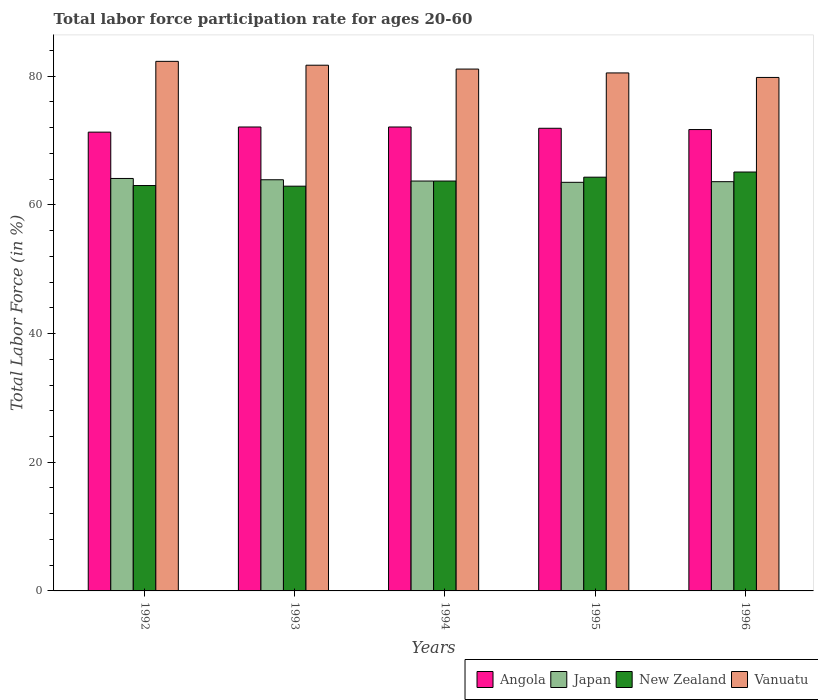How many different coloured bars are there?
Make the answer very short. 4. How many groups of bars are there?
Ensure brevity in your answer.  5. Are the number of bars per tick equal to the number of legend labels?
Offer a very short reply. Yes. What is the label of the 1st group of bars from the left?
Make the answer very short. 1992. What is the labor force participation rate in Vanuatu in 1994?
Give a very brief answer. 81.1. Across all years, what is the maximum labor force participation rate in New Zealand?
Your answer should be very brief. 65.1. Across all years, what is the minimum labor force participation rate in Angola?
Give a very brief answer. 71.3. What is the total labor force participation rate in New Zealand in the graph?
Offer a terse response. 319. What is the difference between the labor force participation rate in Vanuatu in 1993 and that in 1995?
Ensure brevity in your answer.  1.2. What is the difference between the labor force participation rate in Japan in 1994 and the labor force participation rate in New Zealand in 1995?
Keep it short and to the point. -0.6. What is the average labor force participation rate in New Zealand per year?
Ensure brevity in your answer.  63.8. In the year 1995, what is the difference between the labor force participation rate in Japan and labor force participation rate in Angola?
Your response must be concise. -8.4. In how many years, is the labor force participation rate in Japan greater than 60 %?
Keep it short and to the point. 5. What is the ratio of the labor force participation rate in Japan in 1994 to that in 1996?
Provide a short and direct response. 1. Is the difference between the labor force participation rate in Japan in 1992 and 1994 greater than the difference between the labor force participation rate in Angola in 1992 and 1994?
Your response must be concise. Yes. What is the difference between the highest and the second highest labor force participation rate in Japan?
Offer a terse response. 0.2. What is the difference between the highest and the lowest labor force participation rate in Angola?
Your response must be concise. 0.8. What does the 4th bar from the left in 1995 represents?
Keep it short and to the point. Vanuatu. How many bars are there?
Make the answer very short. 20. How many years are there in the graph?
Your answer should be very brief. 5. What is the difference between two consecutive major ticks on the Y-axis?
Your answer should be very brief. 20. Are the values on the major ticks of Y-axis written in scientific E-notation?
Offer a very short reply. No. Does the graph contain grids?
Your answer should be compact. No. How are the legend labels stacked?
Make the answer very short. Horizontal. What is the title of the graph?
Keep it short and to the point. Total labor force participation rate for ages 20-60. Does "Central African Republic" appear as one of the legend labels in the graph?
Provide a short and direct response. No. What is the label or title of the X-axis?
Provide a succinct answer. Years. What is the Total Labor Force (in %) in Angola in 1992?
Provide a succinct answer. 71.3. What is the Total Labor Force (in %) in Japan in 1992?
Provide a succinct answer. 64.1. What is the Total Labor Force (in %) of New Zealand in 1992?
Offer a terse response. 63. What is the Total Labor Force (in %) in Vanuatu in 1992?
Offer a very short reply. 82.3. What is the Total Labor Force (in %) in Angola in 1993?
Give a very brief answer. 72.1. What is the Total Labor Force (in %) of Japan in 1993?
Provide a short and direct response. 63.9. What is the Total Labor Force (in %) of New Zealand in 1993?
Offer a very short reply. 62.9. What is the Total Labor Force (in %) of Vanuatu in 1993?
Your response must be concise. 81.7. What is the Total Labor Force (in %) in Angola in 1994?
Keep it short and to the point. 72.1. What is the Total Labor Force (in %) of Japan in 1994?
Provide a short and direct response. 63.7. What is the Total Labor Force (in %) in New Zealand in 1994?
Provide a short and direct response. 63.7. What is the Total Labor Force (in %) in Vanuatu in 1994?
Your response must be concise. 81.1. What is the Total Labor Force (in %) in Angola in 1995?
Keep it short and to the point. 71.9. What is the Total Labor Force (in %) in Japan in 1995?
Provide a succinct answer. 63.5. What is the Total Labor Force (in %) of New Zealand in 1995?
Provide a succinct answer. 64.3. What is the Total Labor Force (in %) of Vanuatu in 1995?
Give a very brief answer. 80.5. What is the Total Labor Force (in %) of Angola in 1996?
Provide a short and direct response. 71.7. What is the Total Labor Force (in %) in Japan in 1996?
Your answer should be very brief. 63.6. What is the Total Labor Force (in %) in New Zealand in 1996?
Your answer should be compact. 65.1. What is the Total Labor Force (in %) in Vanuatu in 1996?
Offer a terse response. 79.8. Across all years, what is the maximum Total Labor Force (in %) of Angola?
Provide a short and direct response. 72.1. Across all years, what is the maximum Total Labor Force (in %) in Japan?
Offer a very short reply. 64.1. Across all years, what is the maximum Total Labor Force (in %) of New Zealand?
Ensure brevity in your answer.  65.1. Across all years, what is the maximum Total Labor Force (in %) of Vanuatu?
Offer a very short reply. 82.3. Across all years, what is the minimum Total Labor Force (in %) of Angola?
Keep it short and to the point. 71.3. Across all years, what is the minimum Total Labor Force (in %) in Japan?
Ensure brevity in your answer.  63.5. Across all years, what is the minimum Total Labor Force (in %) of New Zealand?
Provide a succinct answer. 62.9. Across all years, what is the minimum Total Labor Force (in %) in Vanuatu?
Give a very brief answer. 79.8. What is the total Total Labor Force (in %) in Angola in the graph?
Offer a very short reply. 359.1. What is the total Total Labor Force (in %) of Japan in the graph?
Offer a very short reply. 318.8. What is the total Total Labor Force (in %) in New Zealand in the graph?
Offer a terse response. 319. What is the total Total Labor Force (in %) of Vanuatu in the graph?
Ensure brevity in your answer.  405.4. What is the difference between the Total Labor Force (in %) of Vanuatu in 1992 and that in 1993?
Your answer should be very brief. 0.6. What is the difference between the Total Labor Force (in %) in New Zealand in 1992 and that in 1994?
Keep it short and to the point. -0.7. What is the difference between the Total Labor Force (in %) of Vanuatu in 1992 and that in 1994?
Your answer should be compact. 1.2. What is the difference between the Total Labor Force (in %) of Japan in 1992 and that in 1995?
Your response must be concise. 0.6. What is the difference between the Total Labor Force (in %) in New Zealand in 1992 and that in 1995?
Ensure brevity in your answer.  -1.3. What is the difference between the Total Labor Force (in %) in Vanuatu in 1992 and that in 1995?
Make the answer very short. 1.8. What is the difference between the Total Labor Force (in %) in Angola in 1992 and that in 1996?
Provide a short and direct response. -0.4. What is the difference between the Total Labor Force (in %) of Angola in 1993 and that in 1994?
Your answer should be very brief. 0. What is the difference between the Total Labor Force (in %) in Japan in 1993 and that in 1994?
Your answer should be very brief. 0.2. What is the difference between the Total Labor Force (in %) in New Zealand in 1993 and that in 1994?
Provide a short and direct response. -0.8. What is the difference between the Total Labor Force (in %) of Angola in 1993 and that in 1996?
Offer a very short reply. 0.4. What is the difference between the Total Labor Force (in %) in Angola in 1994 and that in 1995?
Give a very brief answer. 0.2. What is the difference between the Total Labor Force (in %) in Japan in 1994 and that in 1995?
Offer a very short reply. 0.2. What is the difference between the Total Labor Force (in %) of Angola in 1994 and that in 1996?
Your answer should be very brief. 0.4. What is the difference between the Total Labor Force (in %) of Japan in 1994 and that in 1996?
Your response must be concise. 0.1. What is the difference between the Total Labor Force (in %) in New Zealand in 1994 and that in 1996?
Make the answer very short. -1.4. What is the difference between the Total Labor Force (in %) of Vanuatu in 1994 and that in 1996?
Provide a succinct answer. 1.3. What is the difference between the Total Labor Force (in %) of Angola in 1992 and the Total Labor Force (in %) of New Zealand in 1993?
Your answer should be compact. 8.4. What is the difference between the Total Labor Force (in %) of Angola in 1992 and the Total Labor Force (in %) of Vanuatu in 1993?
Keep it short and to the point. -10.4. What is the difference between the Total Labor Force (in %) in Japan in 1992 and the Total Labor Force (in %) in New Zealand in 1993?
Make the answer very short. 1.2. What is the difference between the Total Labor Force (in %) in Japan in 1992 and the Total Labor Force (in %) in Vanuatu in 1993?
Your response must be concise. -17.6. What is the difference between the Total Labor Force (in %) in New Zealand in 1992 and the Total Labor Force (in %) in Vanuatu in 1993?
Your answer should be very brief. -18.7. What is the difference between the Total Labor Force (in %) in Angola in 1992 and the Total Labor Force (in %) in New Zealand in 1994?
Ensure brevity in your answer.  7.6. What is the difference between the Total Labor Force (in %) in New Zealand in 1992 and the Total Labor Force (in %) in Vanuatu in 1994?
Keep it short and to the point. -18.1. What is the difference between the Total Labor Force (in %) of Japan in 1992 and the Total Labor Force (in %) of New Zealand in 1995?
Keep it short and to the point. -0.2. What is the difference between the Total Labor Force (in %) in Japan in 1992 and the Total Labor Force (in %) in Vanuatu in 1995?
Offer a very short reply. -16.4. What is the difference between the Total Labor Force (in %) of New Zealand in 1992 and the Total Labor Force (in %) of Vanuatu in 1995?
Offer a terse response. -17.5. What is the difference between the Total Labor Force (in %) of Angola in 1992 and the Total Labor Force (in %) of Japan in 1996?
Make the answer very short. 7.7. What is the difference between the Total Labor Force (in %) in Angola in 1992 and the Total Labor Force (in %) in New Zealand in 1996?
Offer a very short reply. 6.2. What is the difference between the Total Labor Force (in %) of Angola in 1992 and the Total Labor Force (in %) of Vanuatu in 1996?
Offer a terse response. -8.5. What is the difference between the Total Labor Force (in %) in Japan in 1992 and the Total Labor Force (in %) in New Zealand in 1996?
Provide a short and direct response. -1. What is the difference between the Total Labor Force (in %) in Japan in 1992 and the Total Labor Force (in %) in Vanuatu in 1996?
Offer a terse response. -15.7. What is the difference between the Total Labor Force (in %) in New Zealand in 1992 and the Total Labor Force (in %) in Vanuatu in 1996?
Your answer should be compact. -16.8. What is the difference between the Total Labor Force (in %) of Japan in 1993 and the Total Labor Force (in %) of New Zealand in 1994?
Your answer should be compact. 0.2. What is the difference between the Total Labor Force (in %) in Japan in 1993 and the Total Labor Force (in %) in Vanuatu in 1994?
Your answer should be very brief. -17.2. What is the difference between the Total Labor Force (in %) of New Zealand in 1993 and the Total Labor Force (in %) of Vanuatu in 1994?
Make the answer very short. -18.2. What is the difference between the Total Labor Force (in %) in Angola in 1993 and the Total Labor Force (in %) in Japan in 1995?
Your answer should be compact. 8.6. What is the difference between the Total Labor Force (in %) in Japan in 1993 and the Total Labor Force (in %) in New Zealand in 1995?
Ensure brevity in your answer.  -0.4. What is the difference between the Total Labor Force (in %) in Japan in 1993 and the Total Labor Force (in %) in Vanuatu in 1995?
Provide a short and direct response. -16.6. What is the difference between the Total Labor Force (in %) of New Zealand in 1993 and the Total Labor Force (in %) of Vanuatu in 1995?
Provide a short and direct response. -17.6. What is the difference between the Total Labor Force (in %) in Angola in 1993 and the Total Labor Force (in %) in Japan in 1996?
Provide a short and direct response. 8.5. What is the difference between the Total Labor Force (in %) in Angola in 1993 and the Total Labor Force (in %) in New Zealand in 1996?
Offer a very short reply. 7. What is the difference between the Total Labor Force (in %) in Japan in 1993 and the Total Labor Force (in %) in New Zealand in 1996?
Ensure brevity in your answer.  -1.2. What is the difference between the Total Labor Force (in %) of Japan in 1993 and the Total Labor Force (in %) of Vanuatu in 1996?
Offer a terse response. -15.9. What is the difference between the Total Labor Force (in %) in New Zealand in 1993 and the Total Labor Force (in %) in Vanuatu in 1996?
Give a very brief answer. -16.9. What is the difference between the Total Labor Force (in %) in Japan in 1994 and the Total Labor Force (in %) in Vanuatu in 1995?
Provide a short and direct response. -16.8. What is the difference between the Total Labor Force (in %) of New Zealand in 1994 and the Total Labor Force (in %) of Vanuatu in 1995?
Your answer should be very brief. -16.8. What is the difference between the Total Labor Force (in %) of Angola in 1994 and the Total Labor Force (in %) of Vanuatu in 1996?
Ensure brevity in your answer.  -7.7. What is the difference between the Total Labor Force (in %) in Japan in 1994 and the Total Labor Force (in %) in Vanuatu in 1996?
Ensure brevity in your answer.  -16.1. What is the difference between the Total Labor Force (in %) of New Zealand in 1994 and the Total Labor Force (in %) of Vanuatu in 1996?
Give a very brief answer. -16.1. What is the difference between the Total Labor Force (in %) of Angola in 1995 and the Total Labor Force (in %) of New Zealand in 1996?
Your response must be concise. 6.8. What is the difference between the Total Labor Force (in %) in Angola in 1995 and the Total Labor Force (in %) in Vanuatu in 1996?
Provide a succinct answer. -7.9. What is the difference between the Total Labor Force (in %) of Japan in 1995 and the Total Labor Force (in %) of New Zealand in 1996?
Ensure brevity in your answer.  -1.6. What is the difference between the Total Labor Force (in %) in Japan in 1995 and the Total Labor Force (in %) in Vanuatu in 1996?
Offer a terse response. -16.3. What is the difference between the Total Labor Force (in %) of New Zealand in 1995 and the Total Labor Force (in %) of Vanuatu in 1996?
Ensure brevity in your answer.  -15.5. What is the average Total Labor Force (in %) in Angola per year?
Offer a very short reply. 71.82. What is the average Total Labor Force (in %) in Japan per year?
Make the answer very short. 63.76. What is the average Total Labor Force (in %) in New Zealand per year?
Offer a terse response. 63.8. What is the average Total Labor Force (in %) of Vanuatu per year?
Ensure brevity in your answer.  81.08. In the year 1992, what is the difference between the Total Labor Force (in %) of Angola and Total Labor Force (in %) of Japan?
Your answer should be very brief. 7.2. In the year 1992, what is the difference between the Total Labor Force (in %) in Angola and Total Labor Force (in %) in Vanuatu?
Offer a very short reply. -11. In the year 1992, what is the difference between the Total Labor Force (in %) of Japan and Total Labor Force (in %) of New Zealand?
Your answer should be compact. 1.1. In the year 1992, what is the difference between the Total Labor Force (in %) in Japan and Total Labor Force (in %) in Vanuatu?
Your answer should be very brief. -18.2. In the year 1992, what is the difference between the Total Labor Force (in %) of New Zealand and Total Labor Force (in %) of Vanuatu?
Your response must be concise. -19.3. In the year 1993, what is the difference between the Total Labor Force (in %) of Angola and Total Labor Force (in %) of Vanuatu?
Give a very brief answer. -9.6. In the year 1993, what is the difference between the Total Labor Force (in %) of Japan and Total Labor Force (in %) of New Zealand?
Give a very brief answer. 1. In the year 1993, what is the difference between the Total Labor Force (in %) in Japan and Total Labor Force (in %) in Vanuatu?
Provide a short and direct response. -17.8. In the year 1993, what is the difference between the Total Labor Force (in %) of New Zealand and Total Labor Force (in %) of Vanuatu?
Keep it short and to the point. -18.8. In the year 1994, what is the difference between the Total Labor Force (in %) of Angola and Total Labor Force (in %) of Japan?
Give a very brief answer. 8.4. In the year 1994, what is the difference between the Total Labor Force (in %) in Angola and Total Labor Force (in %) in New Zealand?
Provide a succinct answer. 8.4. In the year 1994, what is the difference between the Total Labor Force (in %) in Angola and Total Labor Force (in %) in Vanuatu?
Make the answer very short. -9. In the year 1994, what is the difference between the Total Labor Force (in %) of Japan and Total Labor Force (in %) of Vanuatu?
Your answer should be very brief. -17.4. In the year 1994, what is the difference between the Total Labor Force (in %) of New Zealand and Total Labor Force (in %) of Vanuatu?
Ensure brevity in your answer.  -17.4. In the year 1995, what is the difference between the Total Labor Force (in %) of Angola and Total Labor Force (in %) of New Zealand?
Your response must be concise. 7.6. In the year 1995, what is the difference between the Total Labor Force (in %) of Angola and Total Labor Force (in %) of Vanuatu?
Provide a short and direct response. -8.6. In the year 1995, what is the difference between the Total Labor Force (in %) in Japan and Total Labor Force (in %) in New Zealand?
Make the answer very short. -0.8. In the year 1995, what is the difference between the Total Labor Force (in %) of Japan and Total Labor Force (in %) of Vanuatu?
Provide a short and direct response. -17. In the year 1995, what is the difference between the Total Labor Force (in %) in New Zealand and Total Labor Force (in %) in Vanuatu?
Your answer should be very brief. -16.2. In the year 1996, what is the difference between the Total Labor Force (in %) of Angola and Total Labor Force (in %) of Japan?
Keep it short and to the point. 8.1. In the year 1996, what is the difference between the Total Labor Force (in %) in Japan and Total Labor Force (in %) in New Zealand?
Give a very brief answer. -1.5. In the year 1996, what is the difference between the Total Labor Force (in %) of Japan and Total Labor Force (in %) of Vanuatu?
Provide a succinct answer. -16.2. In the year 1996, what is the difference between the Total Labor Force (in %) of New Zealand and Total Labor Force (in %) of Vanuatu?
Your answer should be compact. -14.7. What is the ratio of the Total Labor Force (in %) of Angola in 1992 to that in 1993?
Offer a terse response. 0.99. What is the ratio of the Total Labor Force (in %) in Japan in 1992 to that in 1993?
Provide a succinct answer. 1. What is the ratio of the Total Labor Force (in %) in New Zealand in 1992 to that in 1993?
Your response must be concise. 1. What is the ratio of the Total Labor Force (in %) in Vanuatu in 1992 to that in 1993?
Offer a very short reply. 1.01. What is the ratio of the Total Labor Force (in %) in Angola in 1992 to that in 1994?
Keep it short and to the point. 0.99. What is the ratio of the Total Labor Force (in %) of Japan in 1992 to that in 1994?
Offer a terse response. 1.01. What is the ratio of the Total Labor Force (in %) of New Zealand in 1992 to that in 1994?
Provide a short and direct response. 0.99. What is the ratio of the Total Labor Force (in %) in Vanuatu in 1992 to that in 1994?
Provide a short and direct response. 1.01. What is the ratio of the Total Labor Force (in %) in Japan in 1992 to that in 1995?
Provide a short and direct response. 1.01. What is the ratio of the Total Labor Force (in %) of New Zealand in 1992 to that in 1995?
Offer a terse response. 0.98. What is the ratio of the Total Labor Force (in %) of Vanuatu in 1992 to that in 1995?
Offer a very short reply. 1.02. What is the ratio of the Total Labor Force (in %) in Angola in 1992 to that in 1996?
Your response must be concise. 0.99. What is the ratio of the Total Labor Force (in %) in Japan in 1992 to that in 1996?
Make the answer very short. 1.01. What is the ratio of the Total Labor Force (in %) in Vanuatu in 1992 to that in 1996?
Your answer should be very brief. 1.03. What is the ratio of the Total Labor Force (in %) in Japan in 1993 to that in 1994?
Your answer should be compact. 1. What is the ratio of the Total Labor Force (in %) of New Zealand in 1993 to that in 1994?
Give a very brief answer. 0.99. What is the ratio of the Total Labor Force (in %) of Vanuatu in 1993 to that in 1994?
Ensure brevity in your answer.  1.01. What is the ratio of the Total Labor Force (in %) in New Zealand in 1993 to that in 1995?
Offer a very short reply. 0.98. What is the ratio of the Total Labor Force (in %) in Vanuatu in 1993 to that in 1995?
Your answer should be very brief. 1.01. What is the ratio of the Total Labor Force (in %) in Angola in 1993 to that in 1996?
Provide a succinct answer. 1.01. What is the ratio of the Total Labor Force (in %) of New Zealand in 1993 to that in 1996?
Offer a very short reply. 0.97. What is the ratio of the Total Labor Force (in %) in Vanuatu in 1993 to that in 1996?
Your answer should be compact. 1.02. What is the ratio of the Total Labor Force (in %) of Angola in 1994 to that in 1995?
Offer a terse response. 1. What is the ratio of the Total Labor Force (in %) in New Zealand in 1994 to that in 1995?
Your response must be concise. 0.99. What is the ratio of the Total Labor Force (in %) in Vanuatu in 1994 to that in 1995?
Keep it short and to the point. 1.01. What is the ratio of the Total Labor Force (in %) in Angola in 1994 to that in 1996?
Make the answer very short. 1.01. What is the ratio of the Total Labor Force (in %) in Japan in 1994 to that in 1996?
Offer a terse response. 1. What is the ratio of the Total Labor Force (in %) of New Zealand in 1994 to that in 1996?
Make the answer very short. 0.98. What is the ratio of the Total Labor Force (in %) in Vanuatu in 1994 to that in 1996?
Your answer should be very brief. 1.02. What is the ratio of the Total Labor Force (in %) of Vanuatu in 1995 to that in 1996?
Offer a terse response. 1.01. What is the difference between the highest and the second highest Total Labor Force (in %) in New Zealand?
Offer a very short reply. 0.8. What is the difference between the highest and the lowest Total Labor Force (in %) of Angola?
Offer a terse response. 0.8. What is the difference between the highest and the lowest Total Labor Force (in %) of Japan?
Keep it short and to the point. 0.6. What is the difference between the highest and the lowest Total Labor Force (in %) of New Zealand?
Offer a terse response. 2.2. 